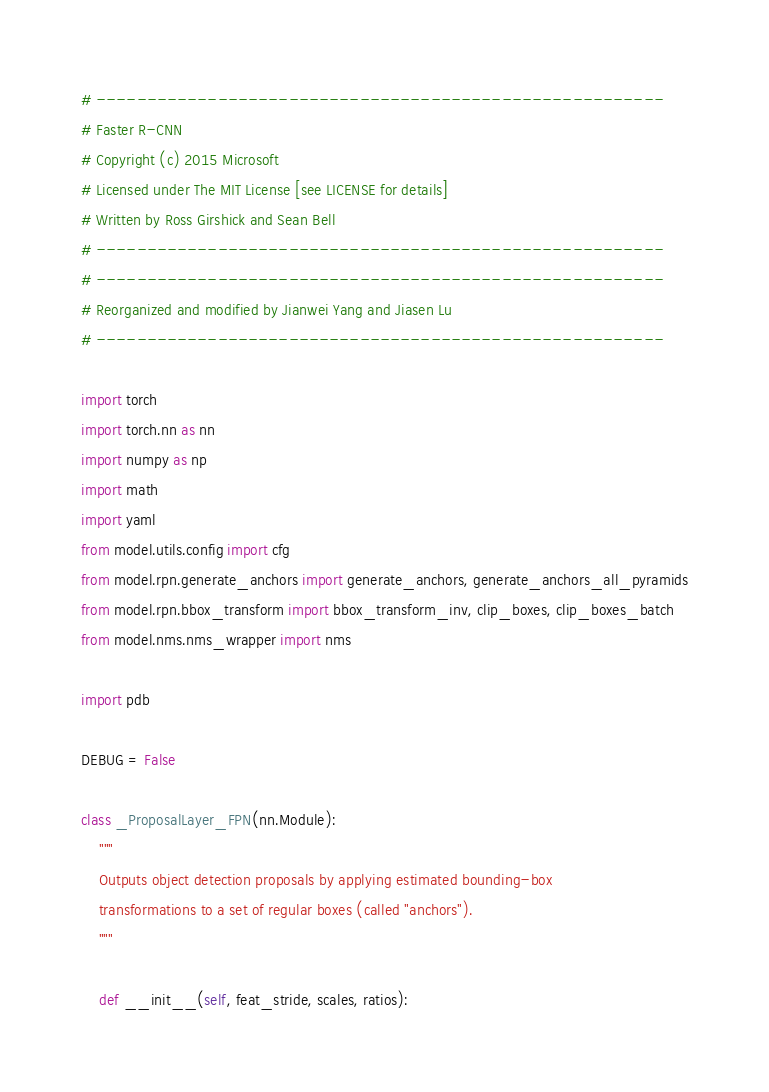Convert code to text. <code><loc_0><loc_0><loc_500><loc_500><_Python_># --------------------------------------------------------
# Faster R-CNN
# Copyright (c) 2015 Microsoft
# Licensed under The MIT License [see LICENSE for details]
# Written by Ross Girshick and Sean Bell
# --------------------------------------------------------
# --------------------------------------------------------
# Reorganized and modified by Jianwei Yang and Jiasen Lu
# --------------------------------------------------------

import torch
import torch.nn as nn
import numpy as np
import math
import yaml
from model.utils.config import cfg
from model.rpn.generate_anchors import generate_anchors, generate_anchors_all_pyramids
from model.rpn.bbox_transform import bbox_transform_inv, clip_boxes, clip_boxes_batch
from model.nms.nms_wrapper import nms

import pdb

DEBUG = False

class _ProposalLayer_FPN(nn.Module):
    """
    Outputs object detection proposals by applying estimated bounding-box
    transformations to a set of regular boxes (called "anchors").
    """

    def __init__(self, feat_stride, scales, ratios):</code> 